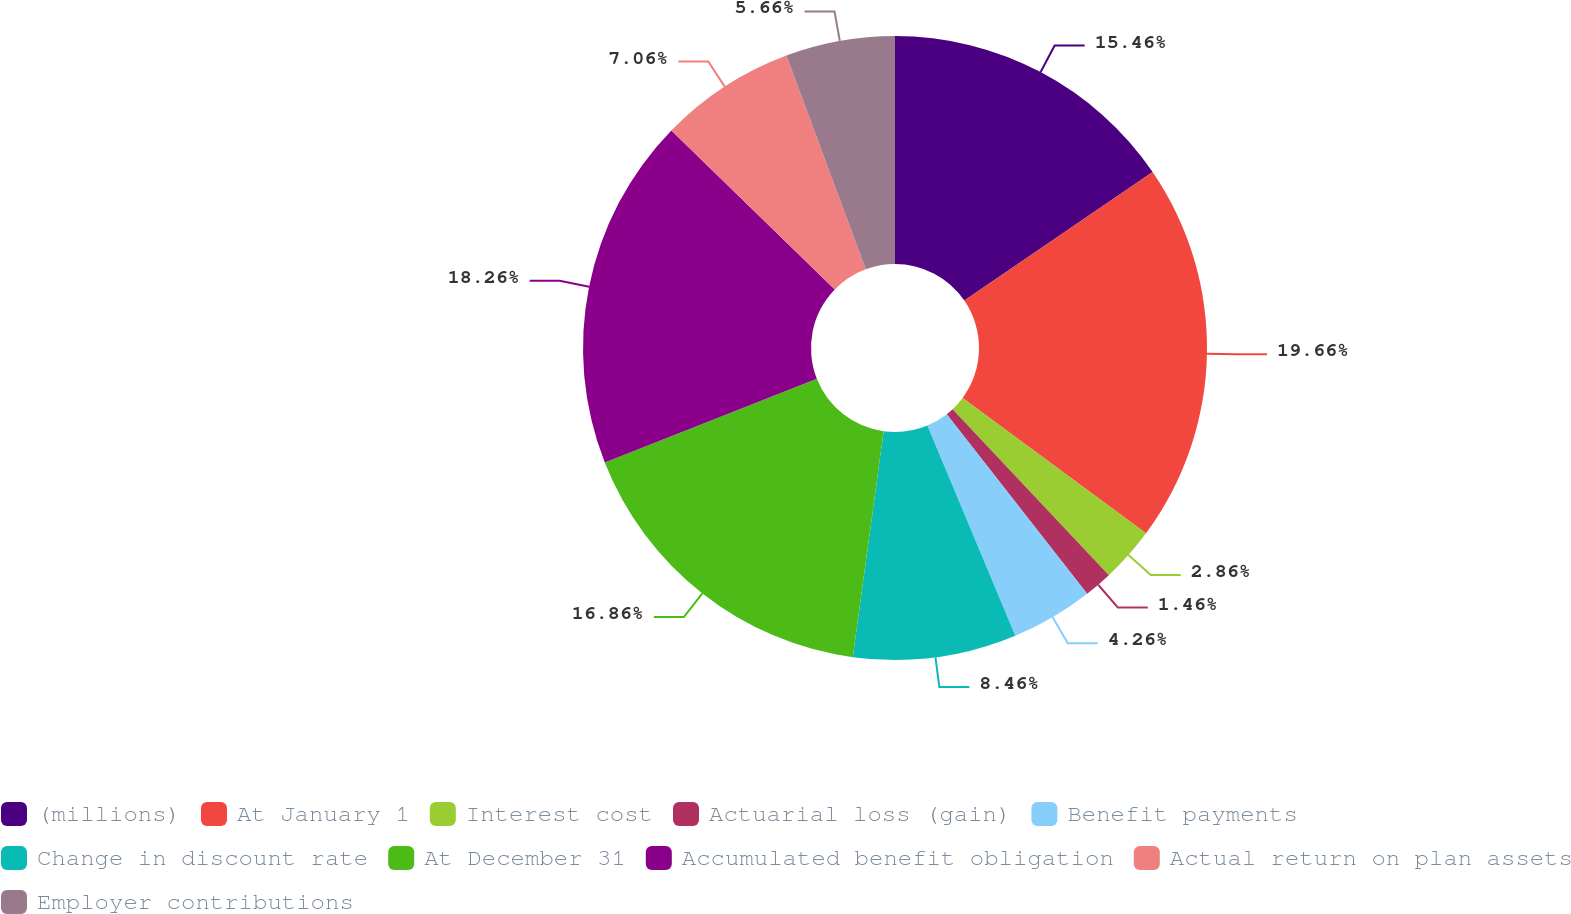Convert chart. <chart><loc_0><loc_0><loc_500><loc_500><pie_chart><fcel>(millions)<fcel>At January 1<fcel>Interest cost<fcel>Actuarial loss (gain)<fcel>Benefit payments<fcel>Change in discount rate<fcel>At December 31<fcel>Accumulated benefit obligation<fcel>Actual return on plan assets<fcel>Employer contributions<nl><fcel>15.46%<fcel>19.66%<fcel>2.86%<fcel>1.46%<fcel>4.26%<fcel>8.46%<fcel>16.86%<fcel>18.26%<fcel>7.06%<fcel>5.66%<nl></chart> 